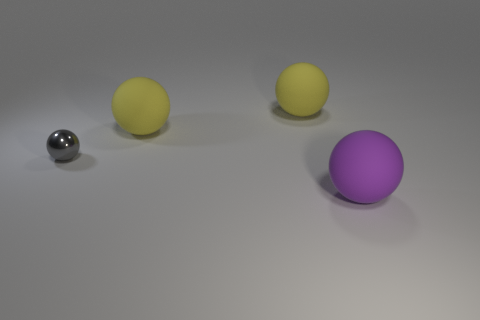Is there any other thing that has the same material as the small gray thing?
Offer a very short reply. No. Is the number of yellow matte balls right of the big purple object greater than the number of small green cylinders?
Offer a terse response. No. How many large objects have the same shape as the small object?
Make the answer very short. 3. What number of purple things have the same size as the shiny sphere?
Your answer should be compact. 0. Is there a large rubber object that has the same color as the metal sphere?
Your answer should be compact. No. How many large balls are behind the object that is in front of the tiny sphere?
Offer a terse response. 2. There is a metallic object; what number of shiny balls are to the right of it?
Offer a terse response. 0. Is the big object that is in front of the tiny metal ball made of the same material as the gray ball?
Ensure brevity in your answer.  No. What color is the tiny metallic thing that is the same shape as the purple rubber thing?
Make the answer very short. Gray. What shape is the small gray thing?
Make the answer very short. Sphere. 